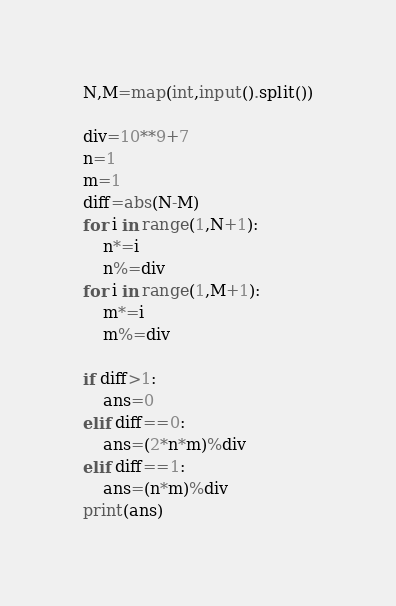Convert code to text. <code><loc_0><loc_0><loc_500><loc_500><_Python_>N,M=map(int,input().split())

div=10**9+7
n=1
m=1
diff=abs(N-M)
for i in range(1,N+1):
    n*=i
    n%=div
for i in range(1,M+1):
    m*=i
    m%=div

if diff>1:
    ans=0
elif diff==0:
    ans=(2*n*m)%div
elif diff==1:
    ans=(n*m)%div
print(ans)</code> 